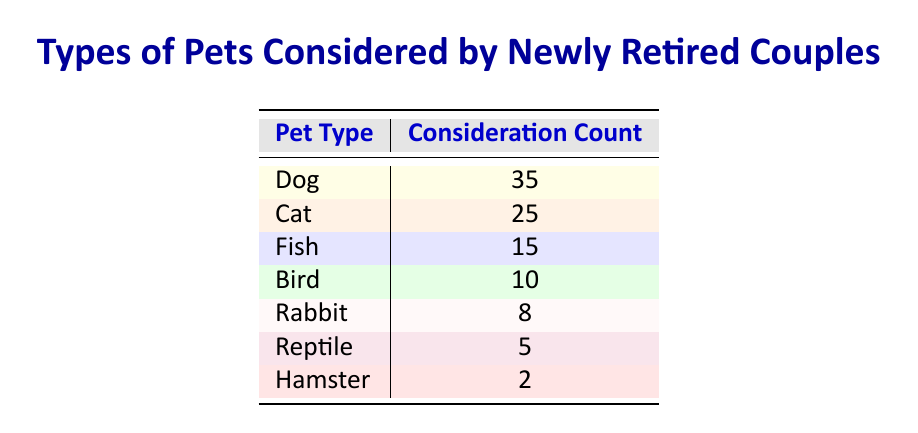What is the most considered pet type among newly retired couples? The table shows that the "Dog" has the highest consideration count at 35, which is greater than any other pet type.
Answer: Dog How many couples considered cats as a pet option? According to the table, the consideration count for "Cat" is 25.
Answer: 25 What is the total number of pets considered by newly retired couples? To find the total, we sum the consideration counts of all pet types: 35 (Dog) + 25 (Cat) + 15 (Fish) + 10 (Bird) + 8 (Rabbit) + 5 (Reptile) + 2 (Hamster) = 100.
Answer: 100 Is it true that more couples considered fish than birds? By looking at the counts, "Fish" has a consideration count of 15 while "Bird" has 10, meaning more couples did consider fish over birds.
Answer: Yes What is the difference in consideration count between dogs and hamsters? The consideration count for "Dog" is 35 and for "Hamster" is 2. The difference is 35 - 2 = 33.
Answer: 33 If we combine the counts of rabbits and reptiles, how many couples considered them? The counts for "Rabbit" and "Reptile" are 8 and 5, respectively. Adding these gives us 8 + 5 = 13.
Answer: 13 Which pet type has the lowest consideration count? The table indicates that "Hamster" has the lowest consideration count with only 2.
Answer: Hamster What percentage of the total consideration count does the cat represent? To find the percentage of cat consideration: (25 / 100) * 100 = 25%.
Answer: 25% How many more newly retired couples considered cats compared to rabbits? The difference between the consideration count for "Cat" (25) and "Rabbit" (8) is 25 - 8 = 17.
Answer: 17 